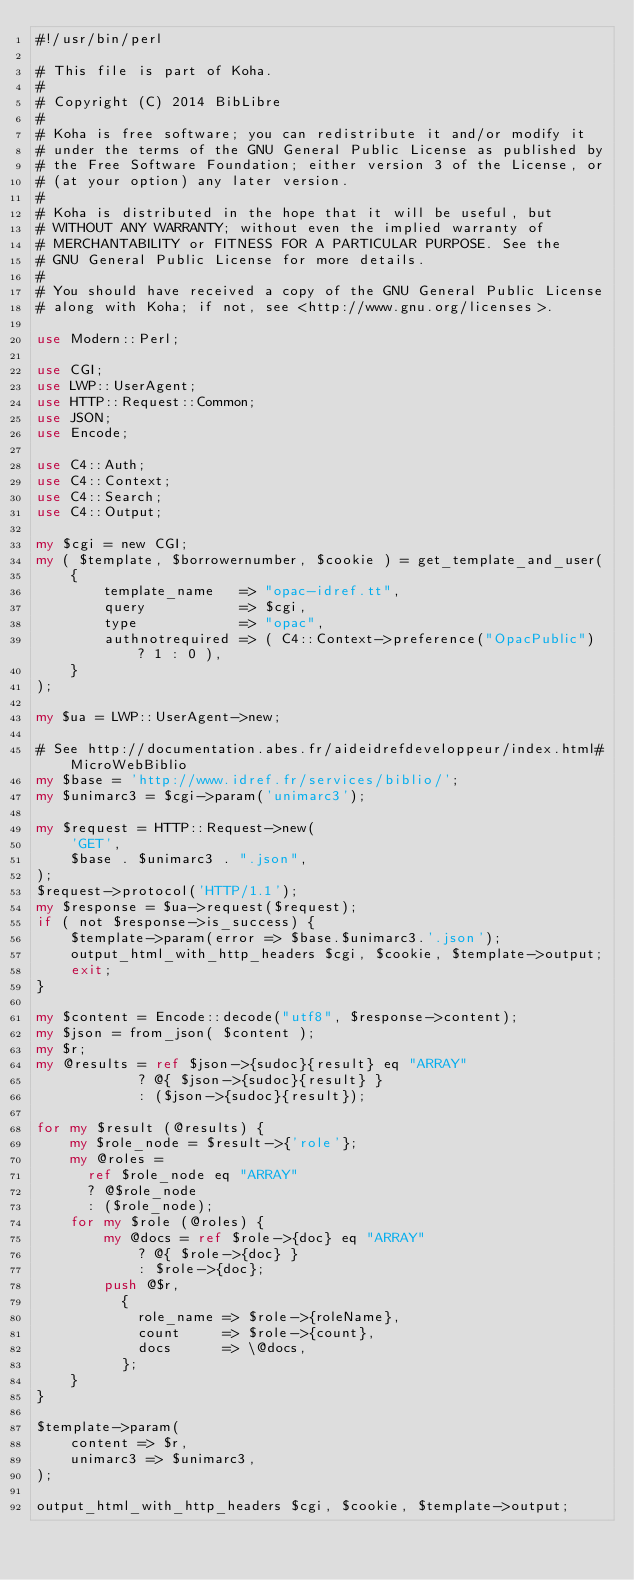<code> <loc_0><loc_0><loc_500><loc_500><_Perl_>#!/usr/bin/perl

# This file is part of Koha.
#
# Copyright (C) 2014 BibLibre
#
# Koha is free software; you can redistribute it and/or modify it
# under the terms of the GNU General Public License as published by
# the Free Software Foundation; either version 3 of the License, or
# (at your option) any later version.
#
# Koha is distributed in the hope that it will be useful, but
# WITHOUT ANY WARRANTY; without even the implied warranty of
# MERCHANTABILITY or FITNESS FOR A PARTICULAR PURPOSE. See the
# GNU General Public License for more details.
#
# You should have received a copy of the GNU General Public License
# along with Koha; if not, see <http://www.gnu.org/licenses>.

use Modern::Perl;

use CGI;
use LWP::UserAgent;
use HTTP::Request::Common;
use JSON;
use Encode;

use C4::Auth;
use C4::Context;
use C4::Search;
use C4::Output;

my $cgi = new CGI;
my ( $template, $borrowernumber, $cookie ) = get_template_and_user(
    {
        template_name   => "opac-idref.tt",
        query           => $cgi,
        type            => "opac",
        authnotrequired => ( C4::Context->preference("OpacPublic") ? 1 : 0 ),
    }
);

my $ua = LWP::UserAgent->new;

# See http://documentation.abes.fr/aideidrefdeveloppeur/index.html#MicroWebBiblio
my $base = 'http://www.idref.fr/services/biblio/';
my $unimarc3 = $cgi->param('unimarc3');

my $request = HTTP::Request->new(
    'GET',
    $base . $unimarc3 . ".json",
);
$request->protocol('HTTP/1.1');
my $response = $ua->request($request);
if ( not $response->is_success) {
    $template->param(error => $base.$unimarc3.'.json');
    output_html_with_http_headers $cgi, $cookie, $template->output;
    exit;
}

my $content = Encode::decode("utf8", $response->content);
my $json = from_json( $content );
my $r;
my @results = ref $json->{sudoc}{result} eq "ARRAY"
            ? @{ $json->{sudoc}{result} }
            : ($json->{sudoc}{result});

for my $result (@results) {
    my $role_node = $result->{'role'};
    my @roles =
      ref $role_node eq "ARRAY"
      ? @$role_node
      : ($role_node);
    for my $role (@roles) {
        my @docs = ref $role->{doc} eq "ARRAY"
            ? @{ $role->{doc} }
            : $role->{doc};
        push @$r,
          {
            role_name => $role->{roleName},
            count     => $role->{count},
            docs      => \@docs,
          };
    }
}

$template->param(
    content => $r,
    unimarc3 => $unimarc3,
);

output_html_with_http_headers $cgi, $cookie, $template->output;
</code> 